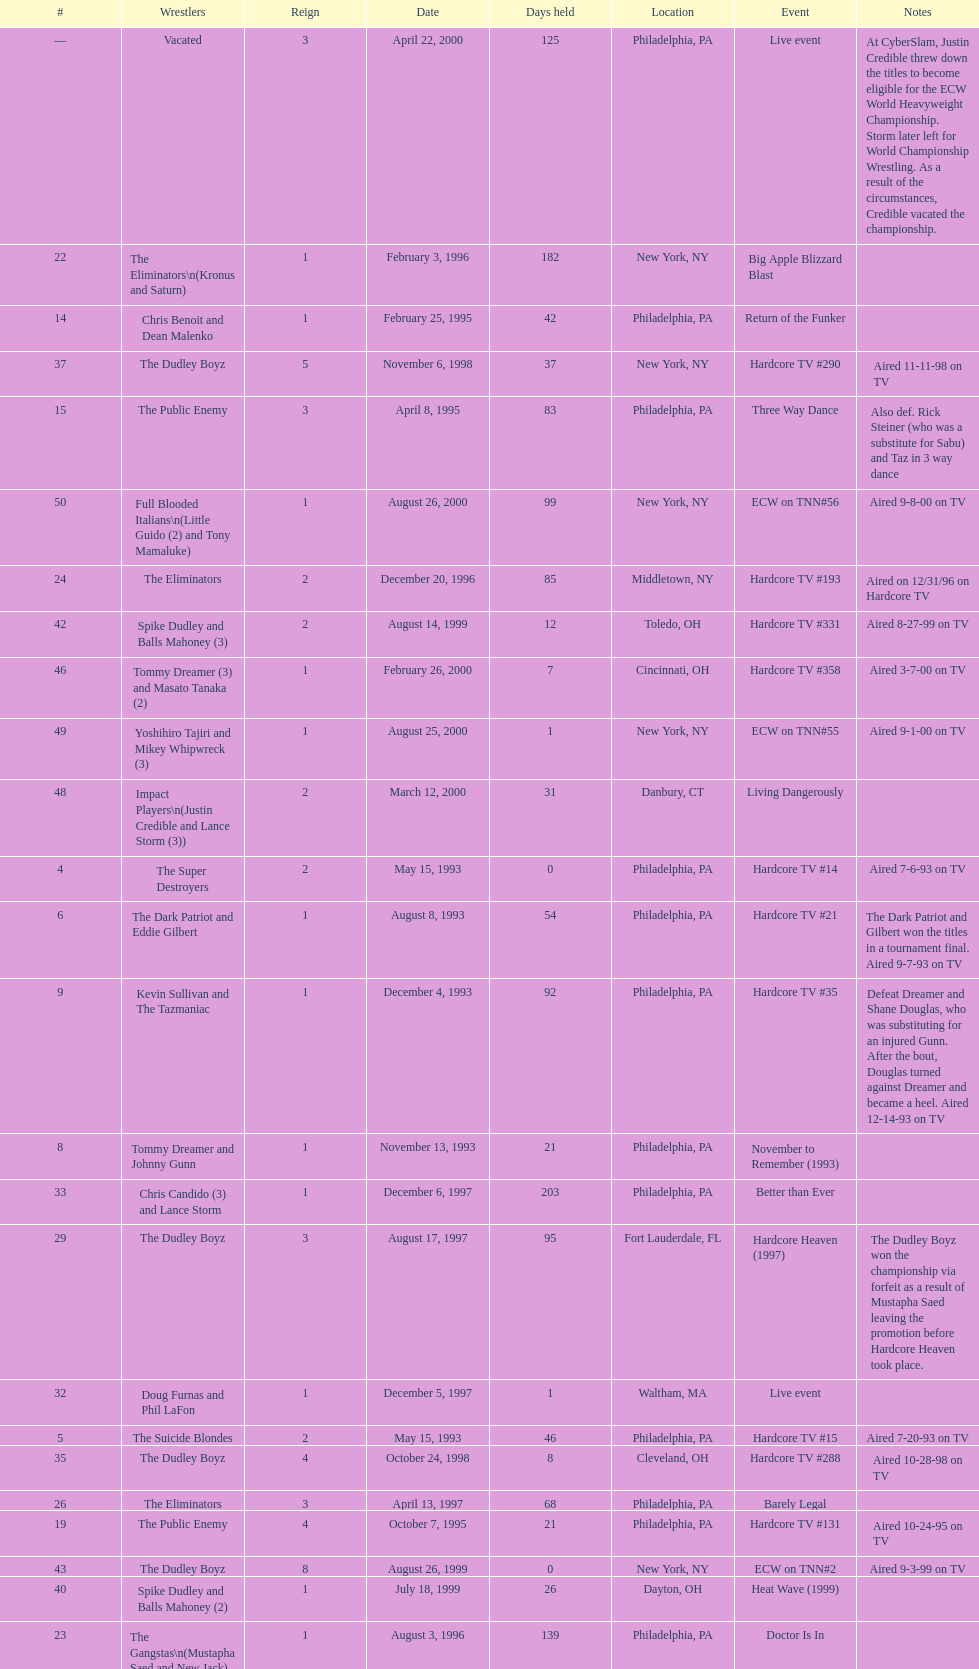How many days did hardcore tv #6 take? 1. 